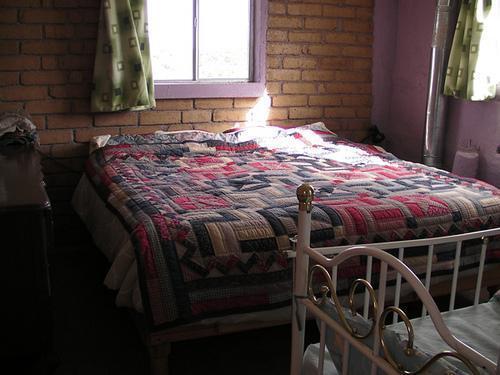How many beds are there?
Give a very brief answer. 2. 